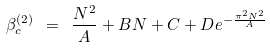<formula> <loc_0><loc_0><loc_500><loc_500>\beta _ { c } ^ { ( 2 ) } \ = \ \frac { N ^ { 2 } } { A } + B N + C + D e ^ { - \frac { \pi ^ { 2 } N ^ { 2 } } { A } }</formula> 